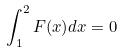Convert formula to latex. <formula><loc_0><loc_0><loc_500><loc_500>\int _ { 1 } ^ { 2 } F ( x ) d x = 0</formula> 